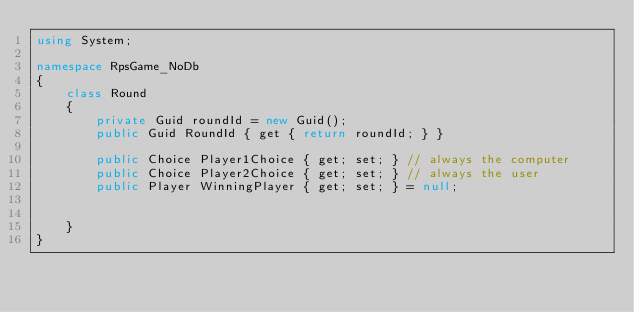<code> <loc_0><loc_0><loc_500><loc_500><_C#_>using System;

namespace RpsGame_NoDb
{
    class Round
    {
        private Guid roundId = new Guid();
        public Guid RoundId { get { return roundId; } }

        public Choice Player1Choice { get; set; } // always the computer
        public Choice Player2Choice { get; set; } // always the user
        public Player WinningPlayer { get; set; } = null;


    }
}</code> 